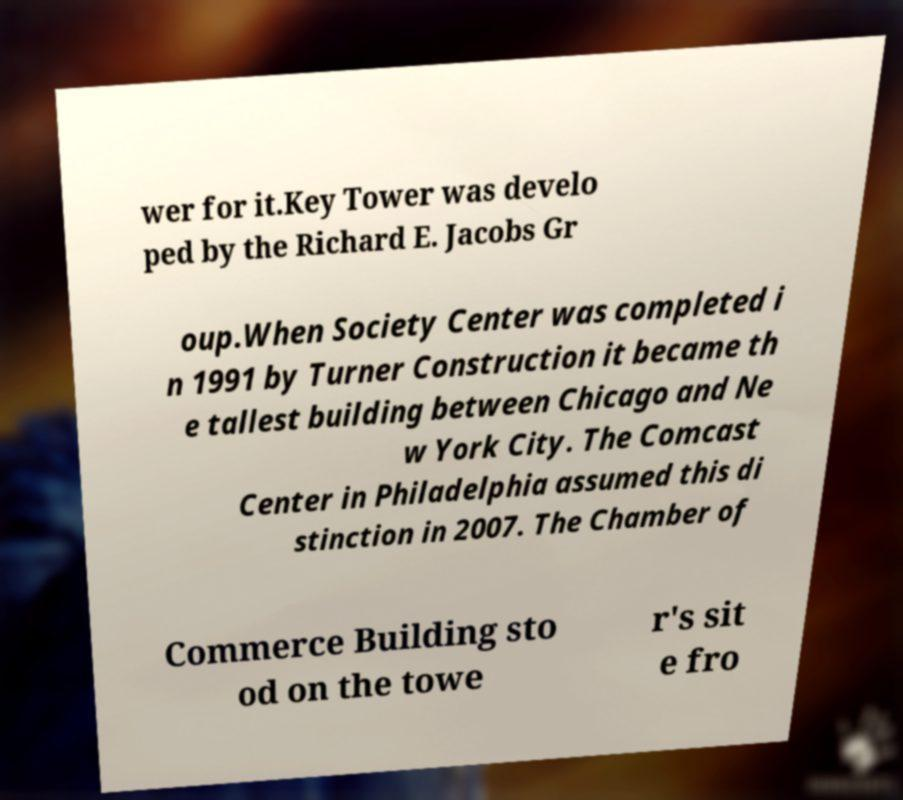For documentation purposes, I need the text within this image transcribed. Could you provide that? wer for it.Key Tower was develo ped by the Richard E. Jacobs Gr oup.When Society Center was completed i n 1991 by Turner Construction it became th e tallest building between Chicago and Ne w York City. The Comcast Center in Philadelphia assumed this di stinction in 2007. The Chamber of Commerce Building sto od on the towe r's sit e fro 